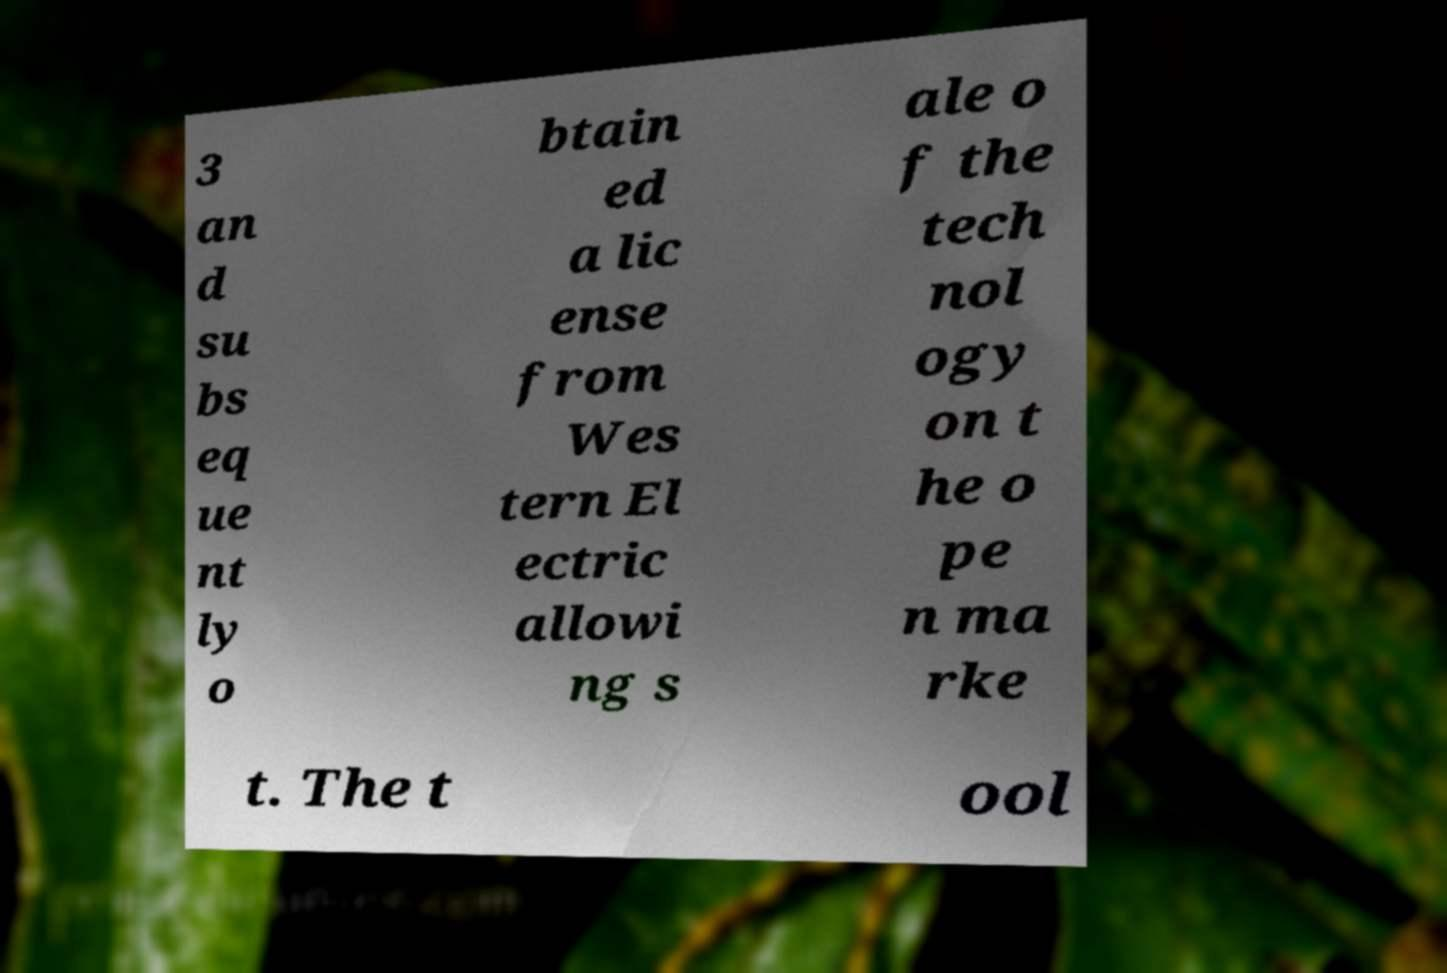Can you accurately transcribe the text from the provided image for me? 3 an d su bs eq ue nt ly o btain ed a lic ense from Wes tern El ectric allowi ng s ale o f the tech nol ogy on t he o pe n ma rke t. The t ool 